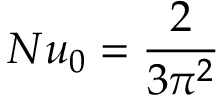Convert formula to latex. <formula><loc_0><loc_0><loc_500><loc_500>N u _ { 0 } = \frac { 2 } { 3 \pi ^ { 2 } }</formula> 